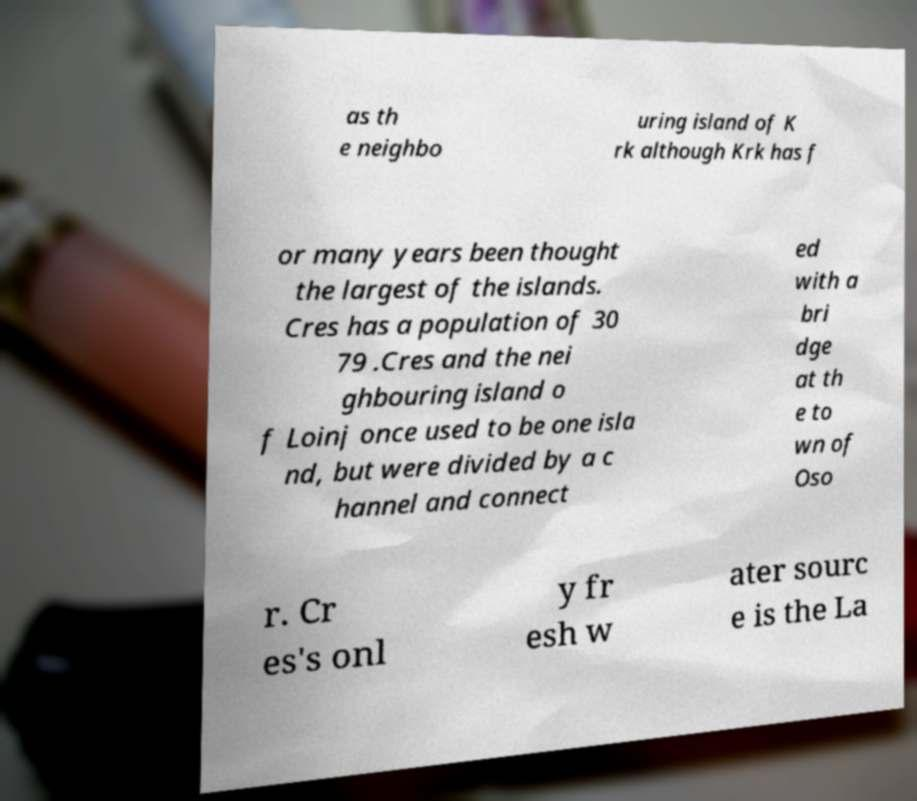Could you assist in decoding the text presented in this image and type it out clearly? as th e neighbo uring island of K rk although Krk has f or many years been thought the largest of the islands. Cres has a population of 30 79 .Cres and the nei ghbouring island o f Loinj once used to be one isla nd, but were divided by a c hannel and connect ed with a bri dge at th e to wn of Oso r. Cr es's onl y fr esh w ater sourc e is the La 